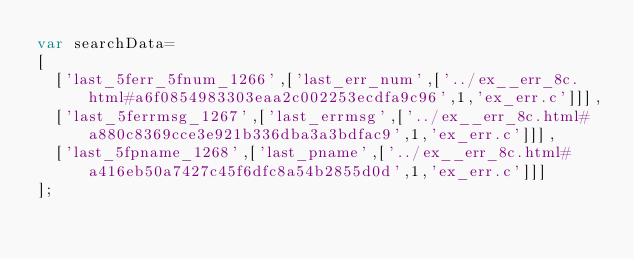<code> <loc_0><loc_0><loc_500><loc_500><_JavaScript_>var searchData=
[
  ['last_5ferr_5fnum_1266',['last_err_num',['../ex__err_8c.html#a6f0854983303eaa2c002253ecdfa9c96',1,'ex_err.c']]],
  ['last_5ferrmsg_1267',['last_errmsg',['../ex__err_8c.html#a880c8369cce3e921b336dba3a3bdfac9',1,'ex_err.c']]],
  ['last_5fpname_1268',['last_pname',['../ex__err_8c.html#a416eb50a7427c45f6dfc8a54b2855d0d',1,'ex_err.c']]]
];
</code> 